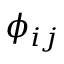<formula> <loc_0><loc_0><loc_500><loc_500>\phi _ { i j }</formula> 